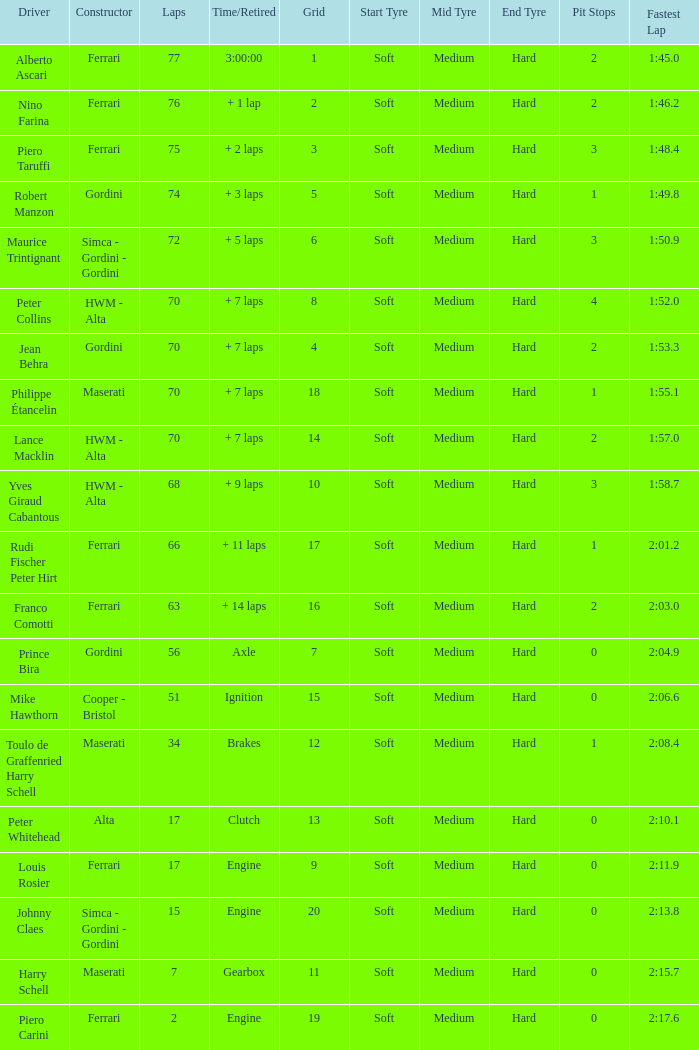Parse the full table. {'header': ['Driver', 'Constructor', 'Laps', 'Time/Retired', 'Grid', 'Start Tyre', 'Mid Tyre', 'End Tyre', 'Pit Stops', 'Fastest Lap'], 'rows': [['Alberto Ascari', 'Ferrari', '77', '3:00:00', '1', 'Soft', 'Medium', 'Hard', '2', '1:45.0'], ['Nino Farina', 'Ferrari', '76', '+ 1 lap', '2', 'Soft', 'Medium', 'Hard', '2', '1:46.2'], ['Piero Taruffi', 'Ferrari', '75', '+ 2 laps', '3', 'Soft', 'Medium', 'Hard', '3', '1:48.4'], ['Robert Manzon', 'Gordini', '74', '+ 3 laps', '5', 'Soft', 'Medium', 'Hard', '1', '1:49.8'], ['Maurice Trintignant', 'Simca - Gordini - Gordini', '72', '+ 5 laps', '6', 'Soft', 'Medium', 'Hard', '3', '1:50.9'], ['Peter Collins', 'HWM - Alta', '70', '+ 7 laps', '8', 'Soft', 'Medium', 'Hard', '4', '1:52.0'], ['Jean Behra', 'Gordini', '70', '+ 7 laps', '4', 'Soft', 'Medium', 'Hard', '2', '1:53.3'], ['Philippe Étancelin', 'Maserati', '70', '+ 7 laps', '18', 'Soft', 'Medium', 'Hard', '1', '1:55.1'], ['Lance Macklin', 'HWM - Alta', '70', '+ 7 laps', '14', 'Soft', 'Medium', 'Hard', '2', '1:57.0'], ['Yves Giraud Cabantous', 'HWM - Alta', '68', '+ 9 laps', '10', 'Soft', 'Medium', 'Hard', '3', '1:58.7'], ['Rudi Fischer Peter Hirt', 'Ferrari', '66', '+ 11 laps', '17', 'Soft', 'Medium', 'Hard', '1', '2:01.2'], ['Franco Comotti', 'Ferrari', '63', '+ 14 laps', '16', 'Soft', 'Medium', 'Hard', '2', '2:03.0'], ['Prince Bira', 'Gordini', '56', 'Axle', '7', 'Soft', 'Medium', 'Hard', '0', '2:04.9'], ['Mike Hawthorn', 'Cooper - Bristol', '51', 'Ignition', '15', 'Soft', 'Medium', 'Hard', '0', '2:06.6'], ['Toulo de Graffenried Harry Schell', 'Maserati', '34', 'Brakes', '12', 'Soft', 'Medium', 'Hard', '1', '2:08.4'], ['Peter Whitehead', 'Alta', '17', 'Clutch', '13', 'Soft', 'Medium', 'Hard', '0', '2:10.1'], ['Louis Rosier', 'Ferrari', '17', 'Engine', '9', 'Soft', 'Medium', 'Hard', '0', '2:11.9'], ['Johnny Claes', 'Simca - Gordini - Gordini', '15', 'Engine', '20', 'Soft', 'Medium', 'Hard', '0', '2:13.8'], ['Harry Schell', 'Maserati', '7', 'Gearbox', '11', 'Soft', 'Medium', 'Hard', '0', '2:15.7'], ['Piero Carini', 'Ferrari', '2', 'Engine', '19', 'Soft', 'Medium', 'Hard', '0', '2:17.6']]} What is the high grid for ferrari's with 2 laps? 19.0. 